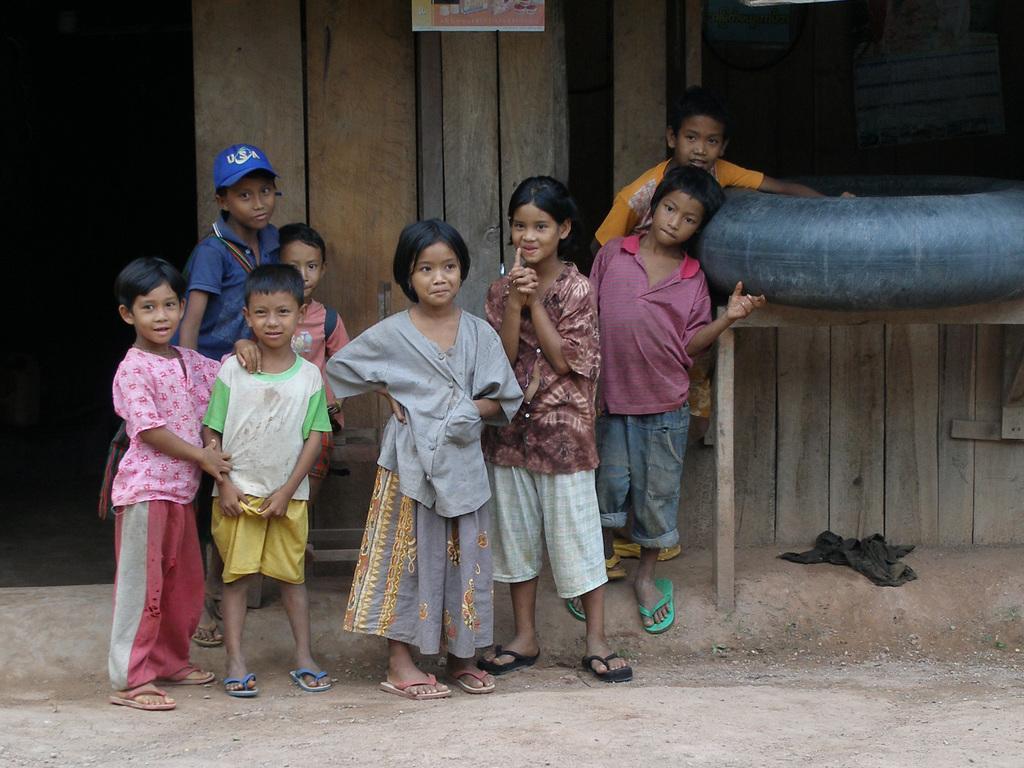Please provide a concise description of this image. Here I can see few children standing on the ground. On the right side there is a table on which there is an object. In the background there is a wooden wall. 